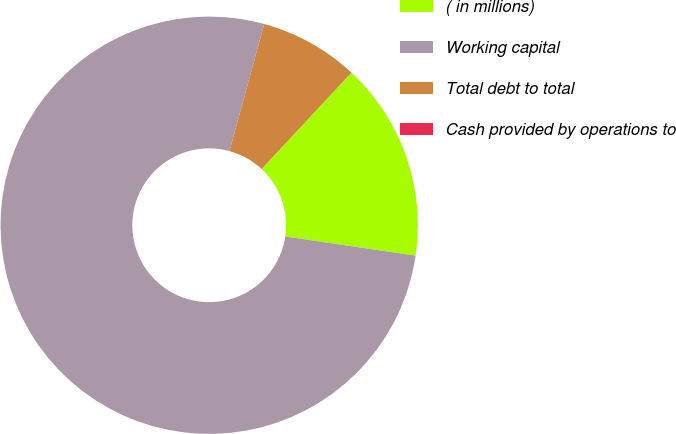Convert chart to OTSL. <chart><loc_0><loc_0><loc_500><loc_500><pie_chart><fcel>( in millions)<fcel>Working capital<fcel>Total debt to total<fcel>Cash provided by operations to<nl><fcel>15.39%<fcel>76.92%<fcel>7.69%<fcel>0.0%<nl></chart> 